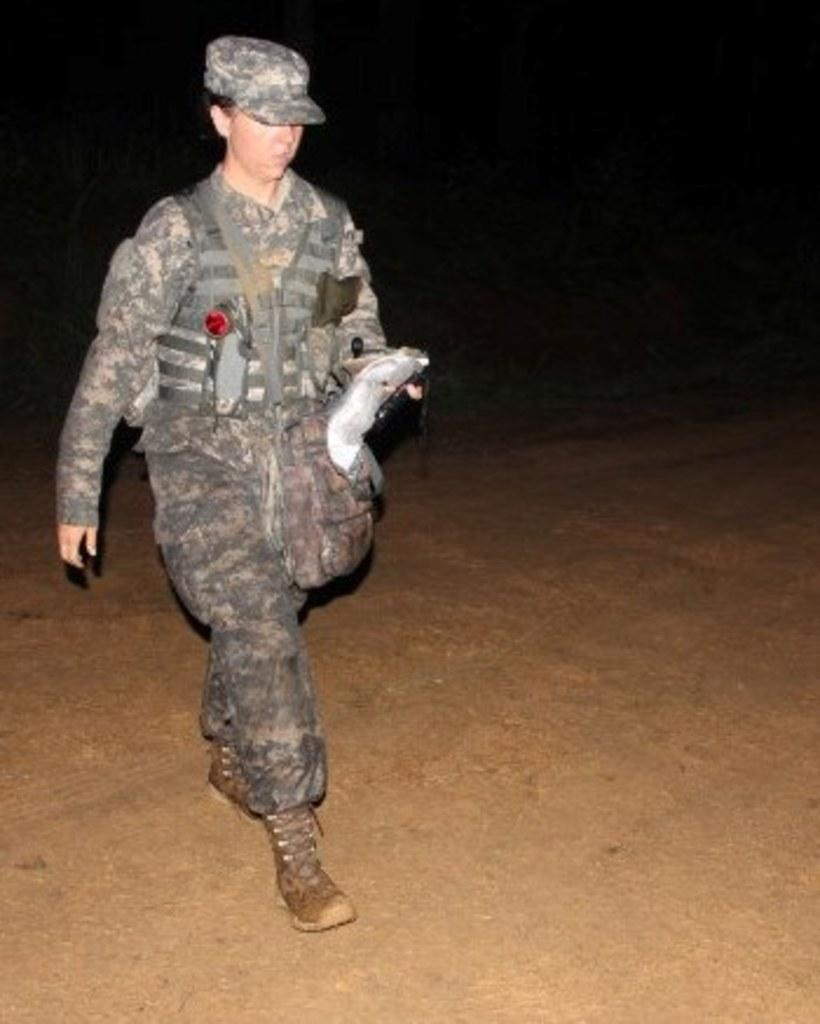What type of person is in the image? There is a military officer in the image. What is the military officer doing? The military officer is walking. What is the military officer holding? The military officer is holding an object. Can you describe the background of the image? The background of the image is blurred. What time does the clock in the image show? There is no clock present in the image. What type of creature can be seen interacting with the military officer in the image? There is no creature present in the image; it only features the military officer. 